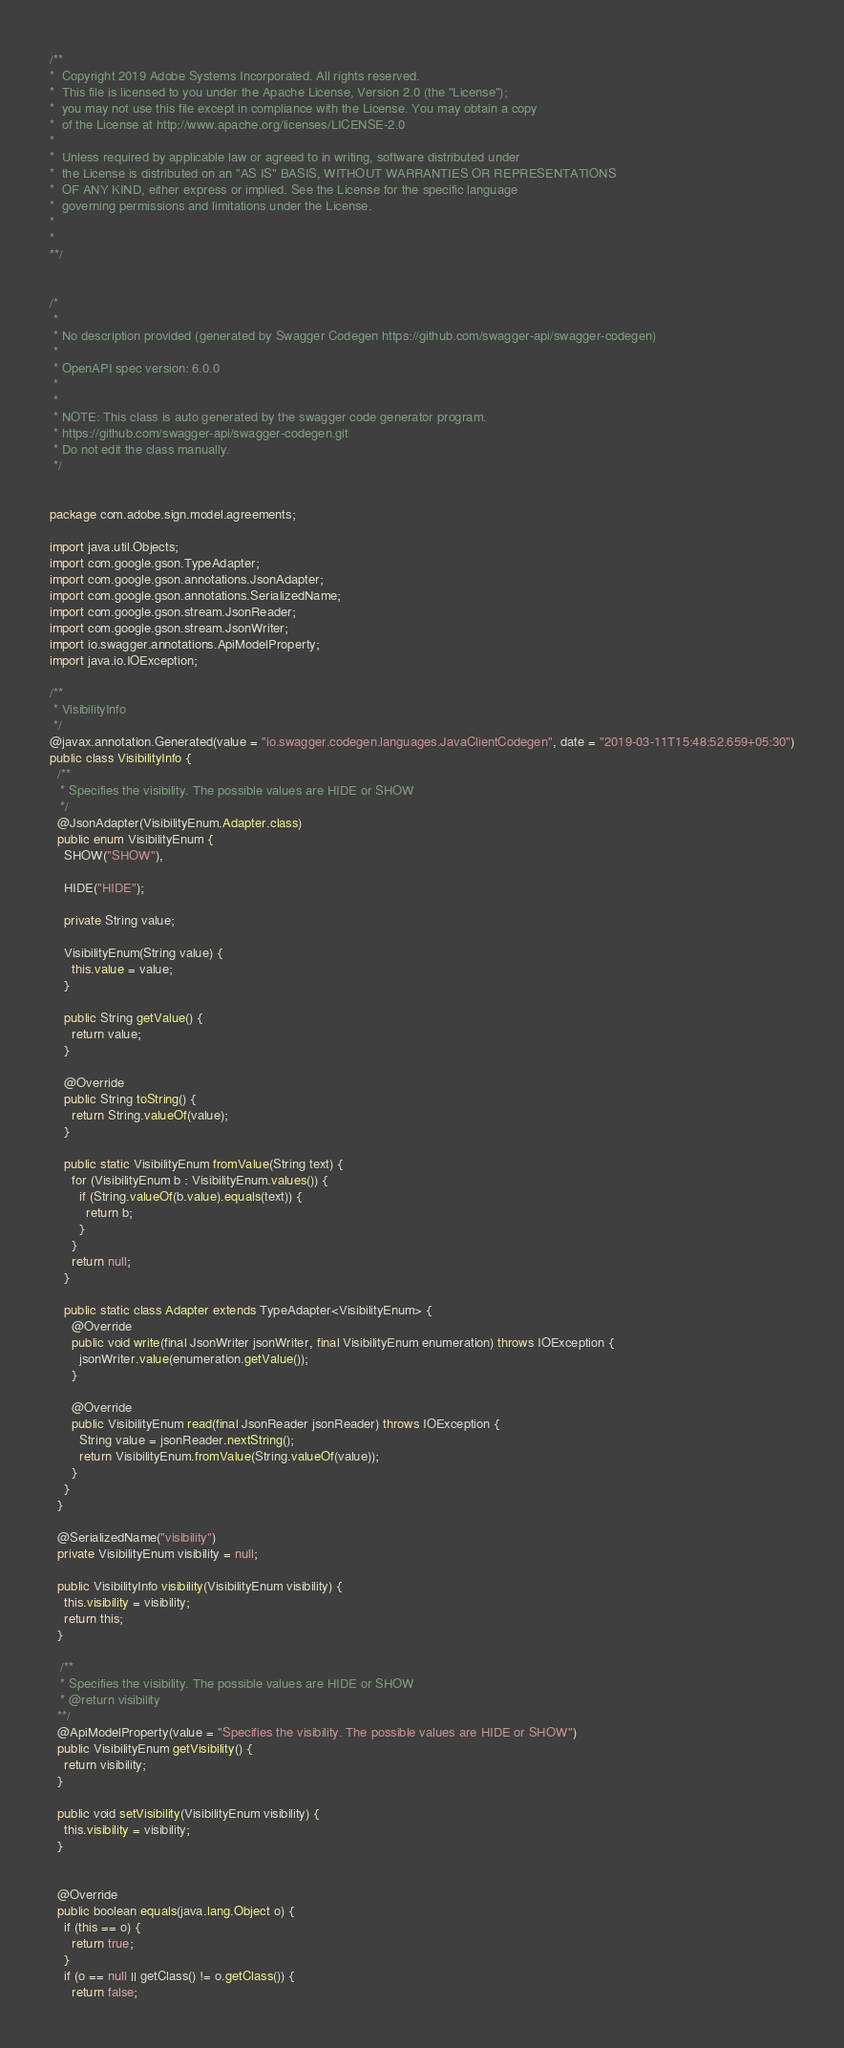Convert code to text. <code><loc_0><loc_0><loc_500><loc_500><_Java_>/**
*  Copyright 2019 Adobe Systems Incorporated. All rights reserved.
*  This file is licensed to you under the Apache License, Version 2.0 (the "License");
*  you may not use this file except in compliance with the License. You may obtain a copy
*  of the License at http://www.apache.org/licenses/LICENSE-2.0
*
*  Unless required by applicable law or agreed to in writing, software distributed under
*  the License is distributed on an "AS IS" BASIS, WITHOUT WARRANTIES OR REPRESENTATIONS
*  OF ANY KIND, either express or implied. See the License for the specific language
*  governing permissions and limitations under the License.
*
*
**/


/*
 * 
 * No description provided (generated by Swagger Codegen https://github.com/swagger-api/swagger-codegen)
 *
 * OpenAPI spec version: 6.0.0
 * 
 *
 * NOTE: This class is auto generated by the swagger code generator program.
 * https://github.com/swagger-api/swagger-codegen.git
 * Do not edit the class manually.
 */


package com.adobe.sign.model.agreements;

import java.util.Objects;
import com.google.gson.TypeAdapter;
import com.google.gson.annotations.JsonAdapter;
import com.google.gson.annotations.SerializedName;
import com.google.gson.stream.JsonReader;
import com.google.gson.stream.JsonWriter;
import io.swagger.annotations.ApiModelProperty;
import java.io.IOException;

/**
 * VisibilityInfo
 */
@javax.annotation.Generated(value = "io.swagger.codegen.languages.JavaClientCodegen", date = "2019-03-11T15:48:52.659+05:30")
public class VisibilityInfo {
  /**
   * Specifies the visibility. The possible values are HIDE or SHOW
   */
  @JsonAdapter(VisibilityEnum.Adapter.class)
  public enum VisibilityEnum {
    SHOW("SHOW"),
    
    HIDE("HIDE");

    private String value;

    VisibilityEnum(String value) {
      this.value = value;
    }

    public String getValue() {
      return value;
    }

    @Override
    public String toString() {
      return String.valueOf(value);
    }

    public static VisibilityEnum fromValue(String text) {
      for (VisibilityEnum b : VisibilityEnum.values()) {
        if (String.valueOf(b.value).equals(text)) {
          return b;
        }
      }
      return null;
    }

    public static class Adapter extends TypeAdapter<VisibilityEnum> {
      @Override
      public void write(final JsonWriter jsonWriter, final VisibilityEnum enumeration) throws IOException {
        jsonWriter.value(enumeration.getValue());
      }

      @Override
      public VisibilityEnum read(final JsonReader jsonReader) throws IOException {
        String value = jsonReader.nextString();
        return VisibilityEnum.fromValue(String.valueOf(value));
      }
    }
  }

  @SerializedName("visibility")
  private VisibilityEnum visibility = null;

  public VisibilityInfo visibility(VisibilityEnum visibility) {
    this.visibility = visibility;
    return this;
  }

   /**
   * Specifies the visibility. The possible values are HIDE or SHOW
   * @return visibility
  **/
  @ApiModelProperty(value = "Specifies the visibility. The possible values are HIDE or SHOW")
  public VisibilityEnum getVisibility() {
    return visibility;
  }

  public void setVisibility(VisibilityEnum visibility) {
    this.visibility = visibility;
  }


  @Override
  public boolean equals(java.lang.Object o) {
    if (this == o) {
      return true;
    }
    if (o == null || getClass() != o.getClass()) {
      return false;</code> 